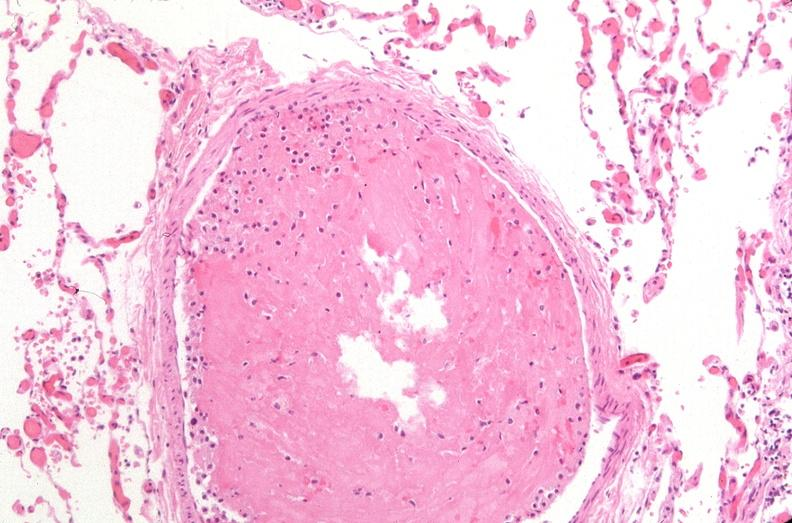where is this?
Answer the question using a single word or phrase. Lung 